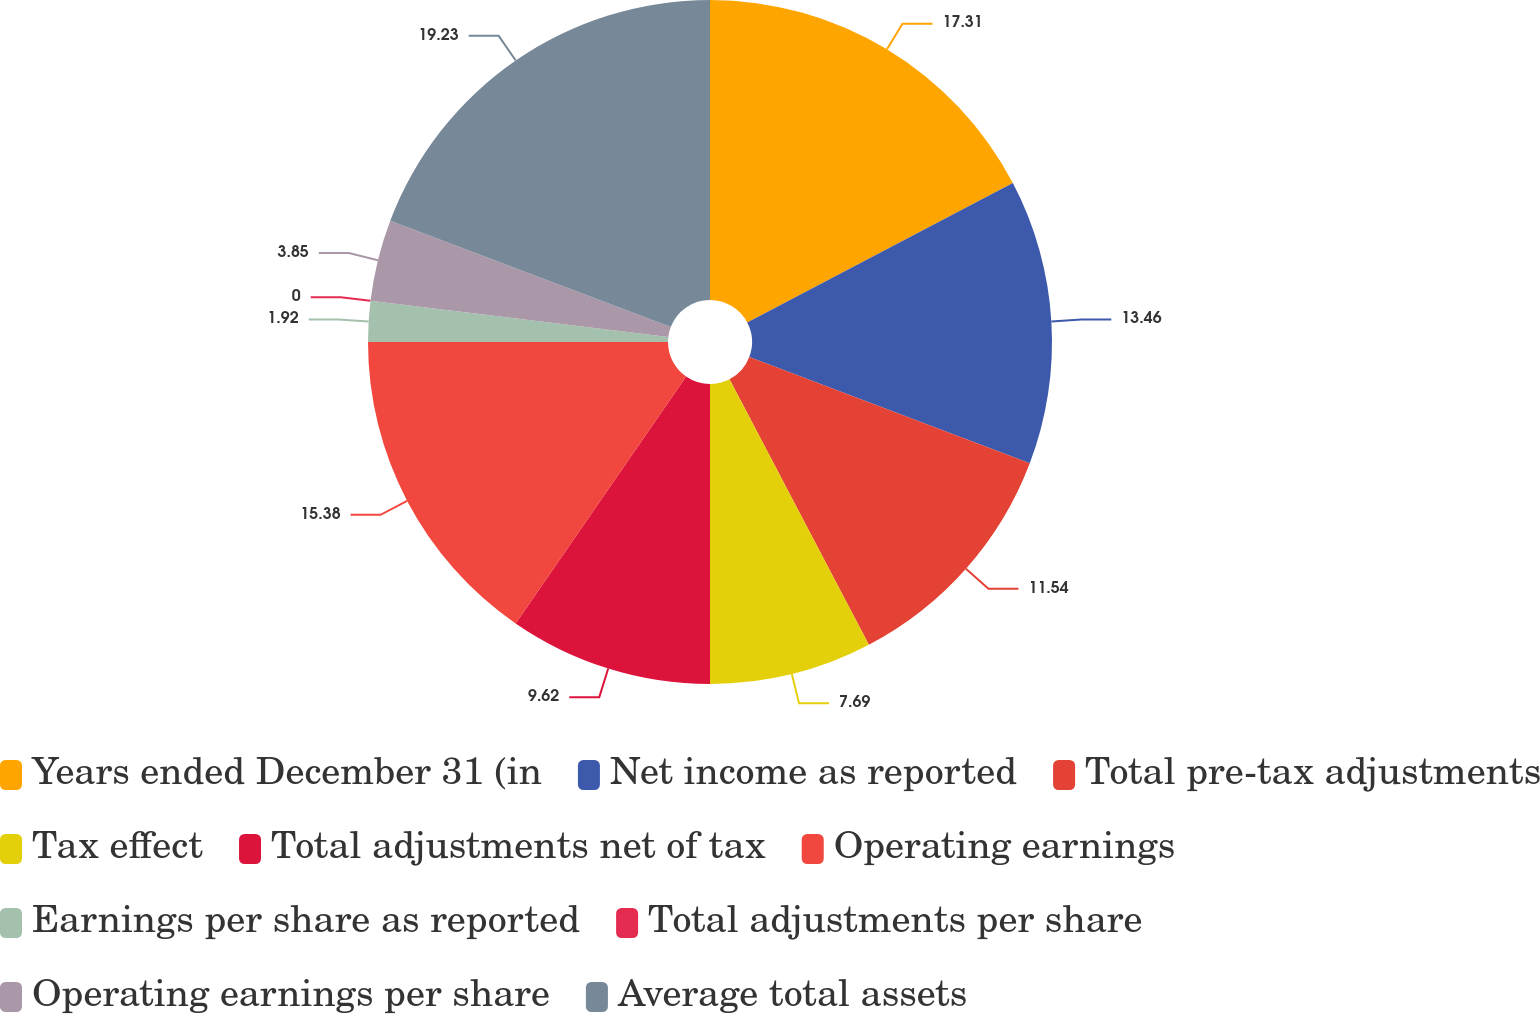Convert chart. <chart><loc_0><loc_0><loc_500><loc_500><pie_chart><fcel>Years ended December 31 (in<fcel>Net income as reported<fcel>Total pre-tax adjustments<fcel>Tax effect<fcel>Total adjustments net of tax<fcel>Operating earnings<fcel>Earnings per share as reported<fcel>Total adjustments per share<fcel>Operating earnings per share<fcel>Average total assets<nl><fcel>17.31%<fcel>13.46%<fcel>11.54%<fcel>7.69%<fcel>9.62%<fcel>15.38%<fcel>1.92%<fcel>0.0%<fcel>3.85%<fcel>19.23%<nl></chart> 